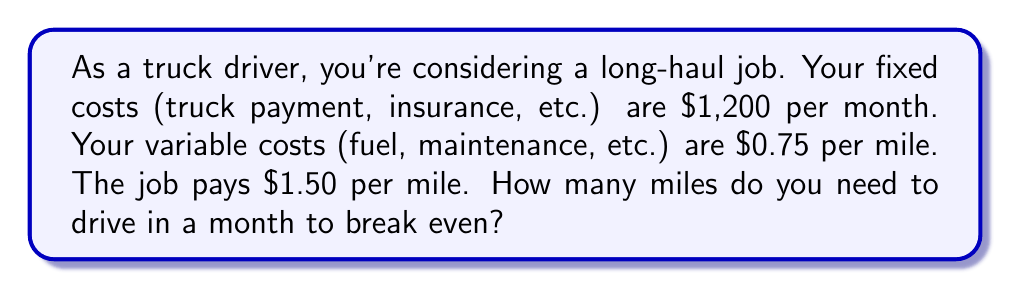Provide a solution to this math problem. Let's approach this step-by-step:

1) First, let's define our variables:
   $x$ = number of miles driven
   $F$ = fixed costs
   $v$ = variable cost per mile
   $p$ = pay per mile

2) We know:
   $F = 1200$
   $v = 0.75$
   $p = 1.50$

3) The break-even point is where total revenue equals total costs:
   $\text{Total Revenue} = \text{Total Costs}$
   $px = F + vx$

4) Let's substitute our known values:
   $1.50x = 1200 + 0.75x$

5) Now, let's solve for $x$:
   $1.50x - 0.75x = 1200$
   $0.75x = 1200$

6) Divide both sides by 0.75:
   $x = \frac{1200}{0.75} = 1600$

Therefore, you need to drive 1,600 miles to break even.

To verify:
Revenue: $1.50 * 1600 = 2400$
Costs: $1200 + (0.75 * 1600) = 2400$

Indeed, at 1,600 miles, revenue equals costs.
Answer: The break-even point is 1,600 miles. 